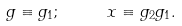<formula> <loc_0><loc_0><loc_500><loc_500>g \equiv g _ { 1 } ; \quad \ x \equiv g _ { 2 } g _ { 1 } .</formula> 